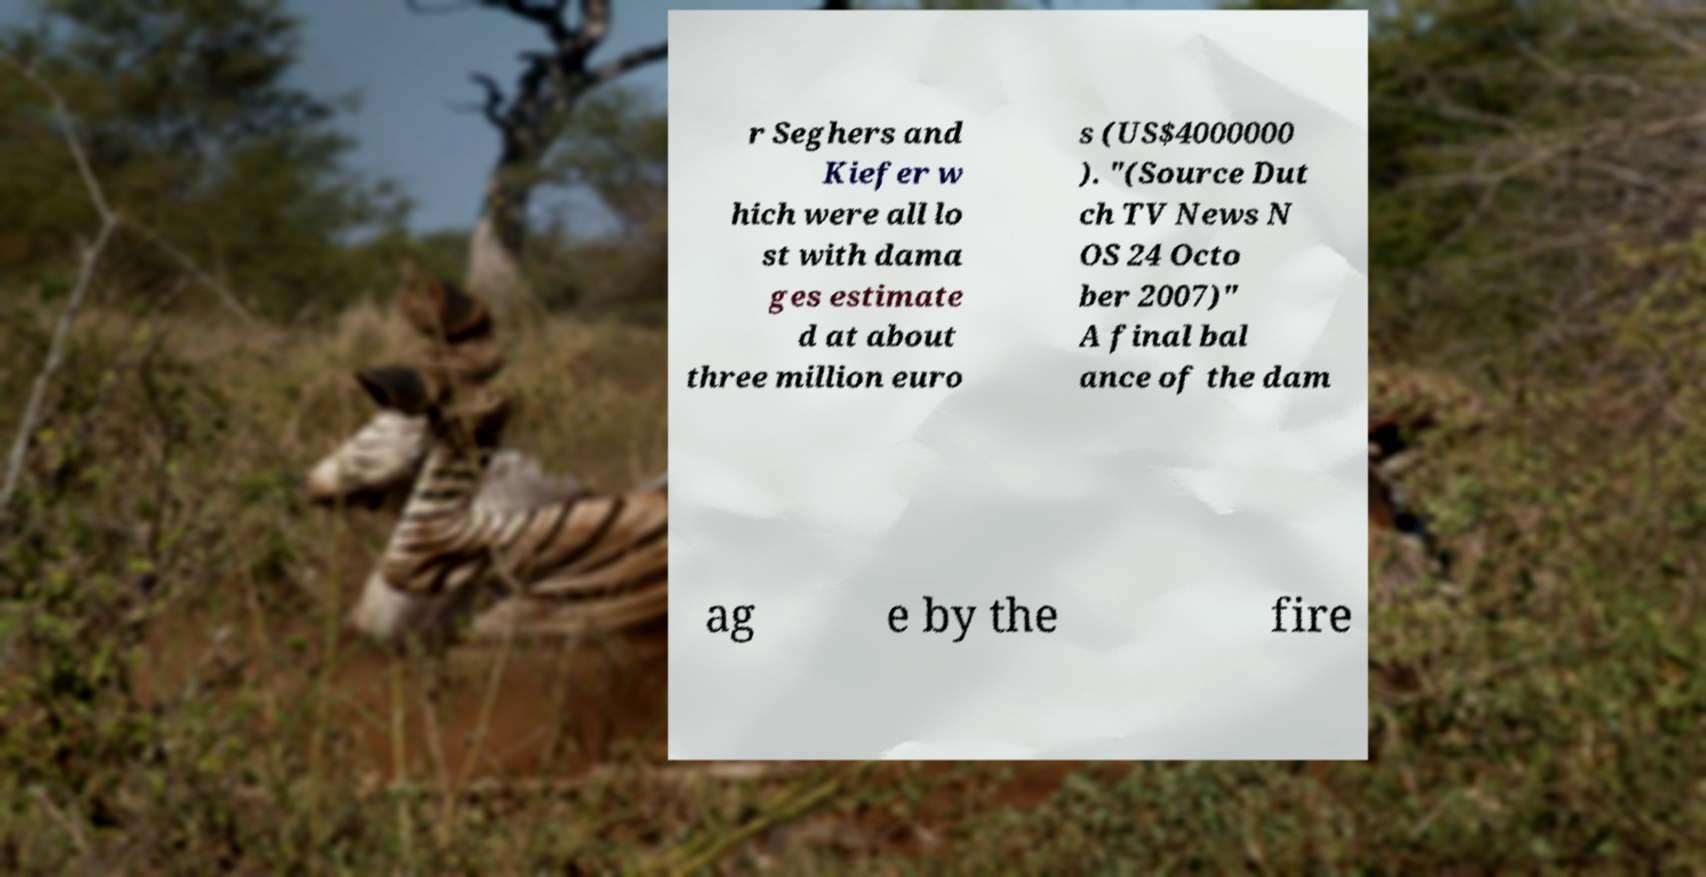Please identify and transcribe the text found in this image. r Seghers and Kiefer w hich were all lo st with dama ges estimate d at about three million euro s (US$4000000 ). "(Source Dut ch TV News N OS 24 Octo ber 2007)" A final bal ance of the dam ag e by the fire 